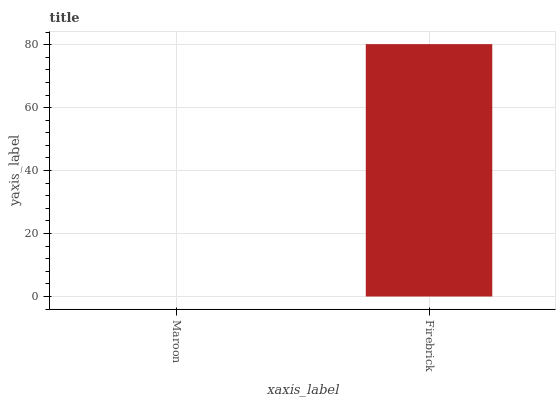Is Firebrick the minimum?
Answer yes or no. No. Is Firebrick greater than Maroon?
Answer yes or no. Yes. Is Maroon less than Firebrick?
Answer yes or no. Yes. Is Maroon greater than Firebrick?
Answer yes or no. No. Is Firebrick less than Maroon?
Answer yes or no. No. Is Firebrick the high median?
Answer yes or no. Yes. Is Maroon the low median?
Answer yes or no. Yes. Is Maroon the high median?
Answer yes or no. No. Is Firebrick the low median?
Answer yes or no. No. 